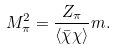<formula> <loc_0><loc_0><loc_500><loc_500>M ^ { 2 } _ { \pi } = \frac { Z _ { \pi } } { \langle \bar { \chi } \chi \rangle } m .</formula> 